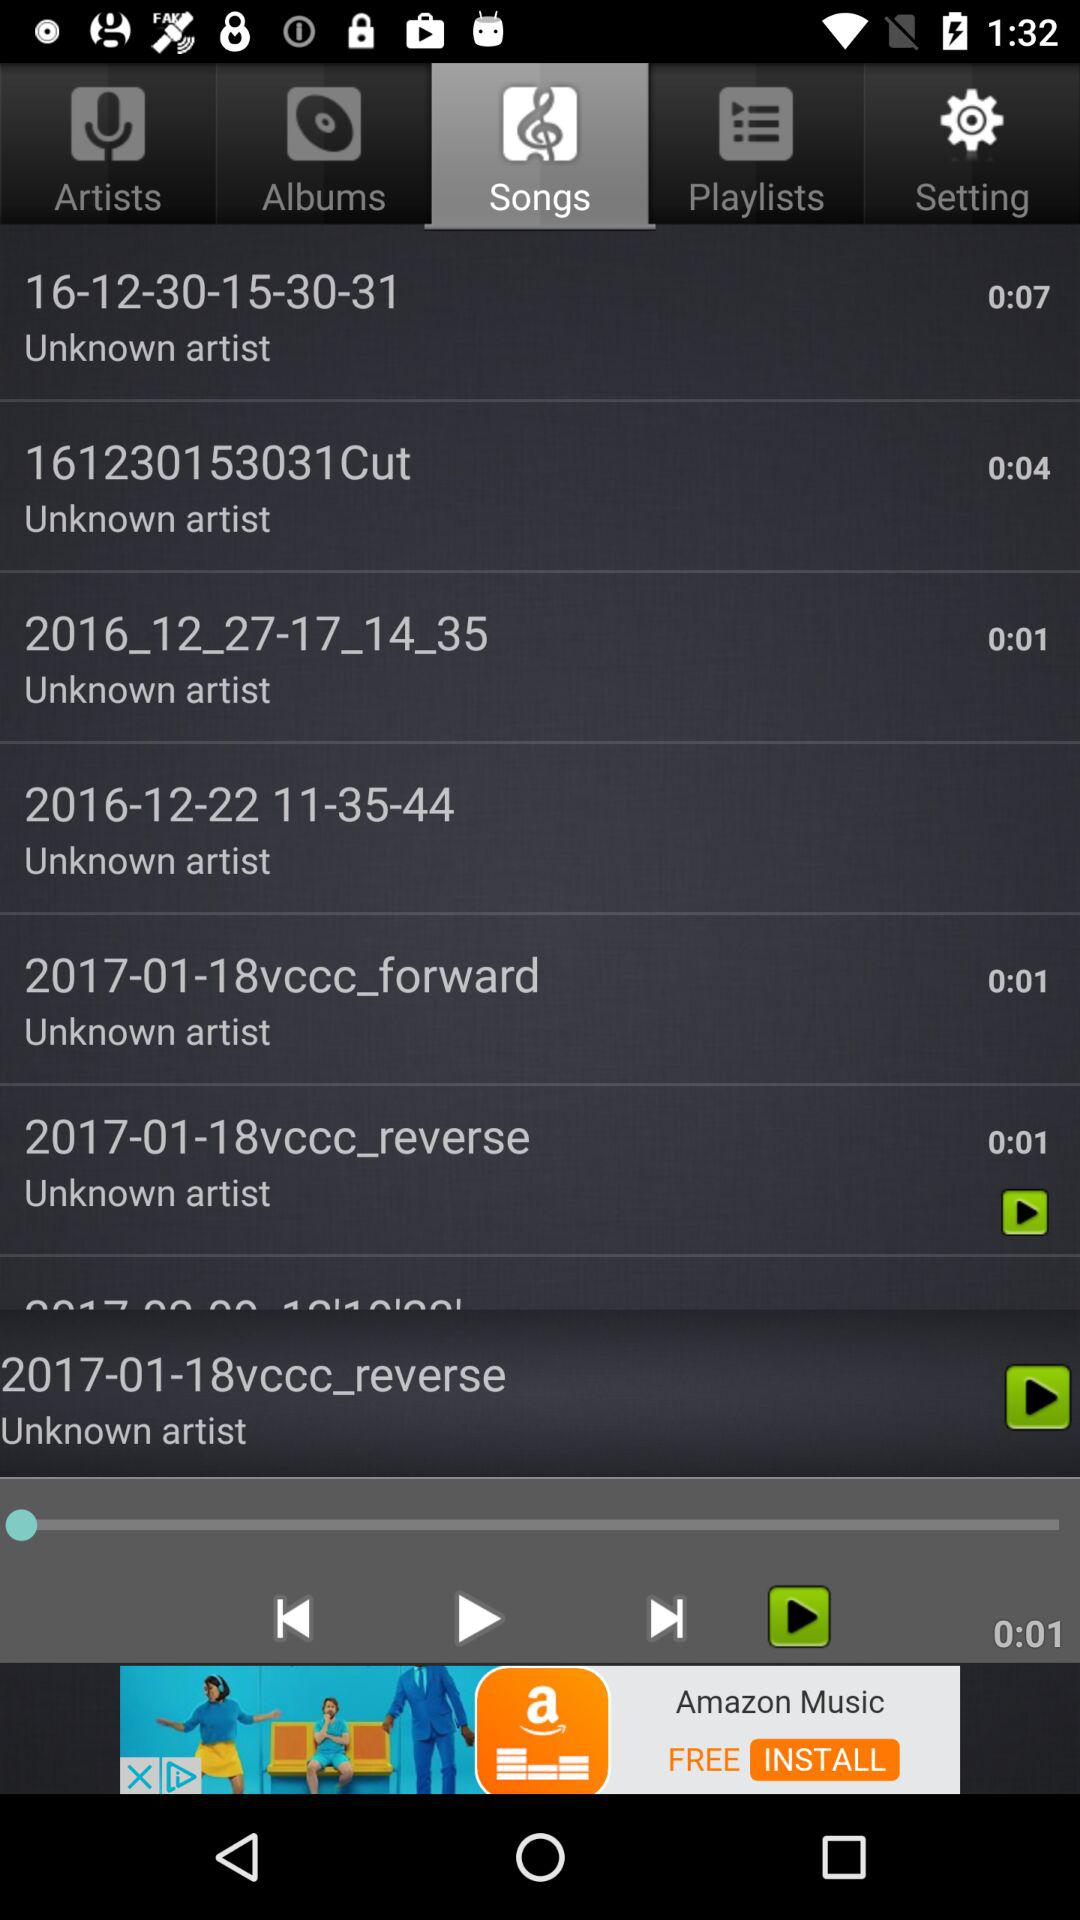Which song was recently played? Recently, the song played was "2017-01-18vccc_reverse". 